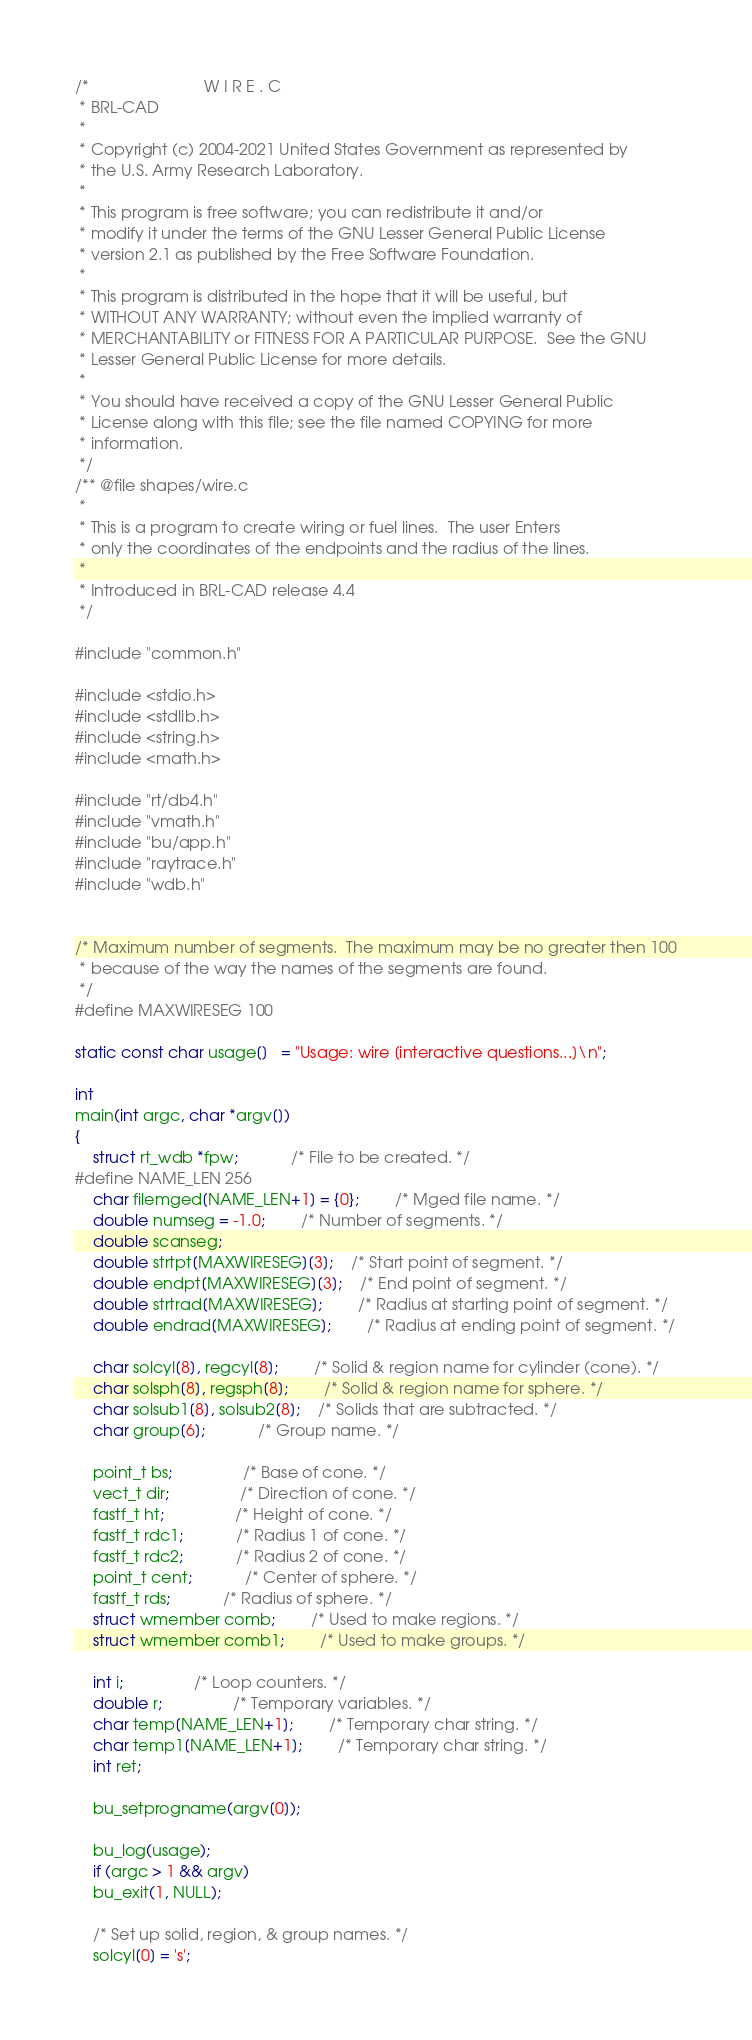<code> <loc_0><loc_0><loc_500><loc_500><_C_>/*                          W I R E . C
 * BRL-CAD
 *
 * Copyright (c) 2004-2021 United States Government as represented by
 * the U.S. Army Research Laboratory.
 *
 * This program is free software; you can redistribute it and/or
 * modify it under the terms of the GNU Lesser General Public License
 * version 2.1 as published by the Free Software Foundation.
 *
 * This program is distributed in the hope that it will be useful, but
 * WITHOUT ANY WARRANTY; without even the implied warranty of
 * MERCHANTABILITY or FITNESS FOR A PARTICULAR PURPOSE.  See the GNU
 * Lesser General Public License for more details.
 *
 * You should have received a copy of the GNU Lesser General Public
 * License along with this file; see the file named COPYING for more
 * information.
 */
/** @file shapes/wire.c
 *
 * This is a program to create wiring or fuel lines.  The user Enters
 * only the coordinates of the endpoints and the radius of the lines.
 *
 * Introduced in BRL-CAD release 4.4
 */

#include "common.h"

#include <stdio.h>
#include <stdlib.h>
#include <string.h>
#include <math.h>

#include "rt/db4.h"
#include "vmath.h"
#include "bu/app.h"
#include "raytrace.h"
#include "wdb.h"


/* Maximum number of segments.  The maximum may be no greater then 100
 * because of the way the names of the segments are found.
 */
#define MAXWIRESEG 100

static const char usage[]   = "Usage: wire [interactive questions...]\n";

int
main(int argc, char *argv[])
{
    struct rt_wdb *fpw;			/* File to be created. */
#define NAME_LEN 256
    char filemged[NAME_LEN+1] = {0};		/* Mged file name. */
    double numseg = -1.0;		/* Number of segments. */
    double scanseg;
    double strtpt[MAXWIRESEG][3];	/* Start point of segment. */
    double endpt[MAXWIRESEG][3];	/* End point of segment. */
    double strtrad[MAXWIRESEG];		/* Radius at starting point of segment. */
    double endrad[MAXWIRESEG];		/* Radius at ending point of segment. */

    char solcyl[8], regcyl[8];		/* Solid & region name for cylinder (cone). */
    char solsph[8], regsph[8];		/* Solid & region name for sphere. */
    char solsub1[8], solsub2[8];	/* Solids that are subtracted. */
    char group[6];			/* Group name. */

    point_t bs;				/* Base of cone. */
    vect_t dir;				/* Direction of cone. */
    fastf_t ht;				/* Height of cone. */
    fastf_t rdc1;			/* Radius 1 of cone. */
    fastf_t rdc2;			/* Radius 2 of cone. */
    point_t cent;			/* Center of sphere. */
    fastf_t rds;			/* Radius of sphere. */
    struct wmember comb;		/* Used to make regions. */
    struct wmember comb1;		/* Used to make groups. */

    int i;				/* Loop counters. */
    double r;				/* Temporary variables. */
    char temp[NAME_LEN+1];		/* Temporary char string. */
    char temp1[NAME_LEN+1];		/* Temporary char string. */
    int ret;

    bu_setprogname(argv[0]);

    bu_log(usage);
    if (argc > 1 && argv)
	bu_exit(1, NULL);

    /* Set up solid, region, & group names. */
    solcyl[0] = 's';</code> 